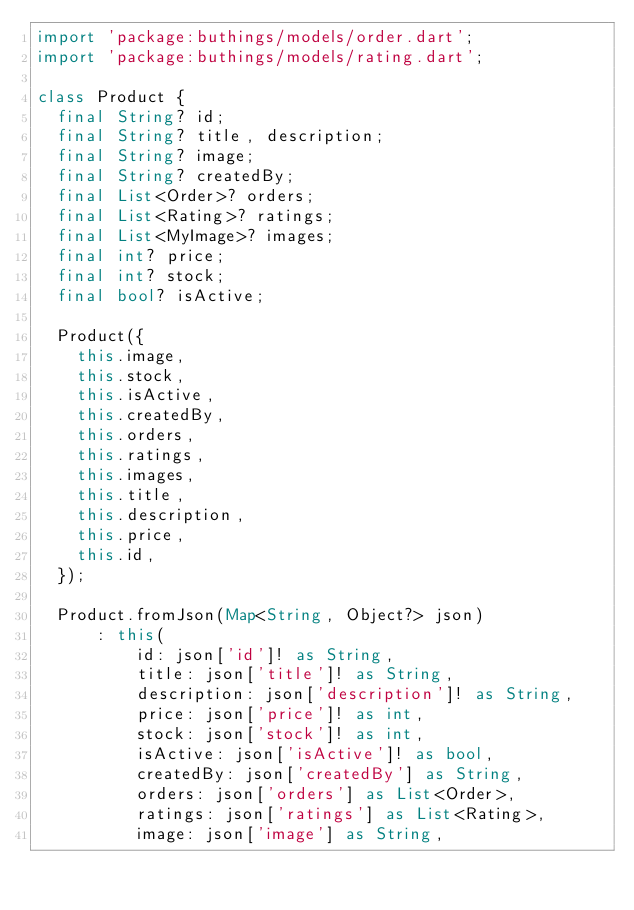Convert code to text. <code><loc_0><loc_0><loc_500><loc_500><_Dart_>import 'package:buthings/models/order.dart';
import 'package:buthings/models/rating.dart';

class Product {
  final String? id;
  final String? title, description;
  final String? image;
  final String? createdBy;
  final List<Order>? orders;
  final List<Rating>? ratings;
  final List<MyImage>? images;
  final int? price;
  final int? stock;
  final bool? isActive;

  Product({
    this.image,
    this.stock,
    this.isActive,
    this.createdBy,
    this.orders,
    this.ratings,
    this.images,
    this.title,
    this.description,
    this.price,
    this.id,
  });

  Product.fromJson(Map<String, Object?> json)
      : this(
          id: json['id']! as String,
          title: json['title']! as String,
          description: json['description']! as String,
          price: json['price']! as int,
          stock: json['stock']! as int,
          isActive: json['isActive']! as bool,
          createdBy: json['createdBy'] as String,
          orders: json['orders'] as List<Order>,
          ratings: json['ratings'] as List<Rating>,
          image: json['image'] as String,</code> 